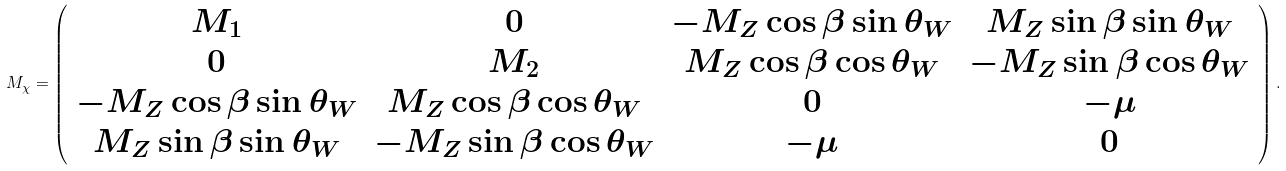Convert formula to latex. <formula><loc_0><loc_0><loc_500><loc_500>M _ { \chi } = \left ( \begin{array} { c c c c } M _ { 1 } & 0 & - M _ { Z } \cos \beta \sin \theta _ { W } & M _ { Z } \sin \beta \sin \theta _ { W } \\ 0 & M _ { 2 } & M _ { Z } \cos \beta \cos \theta _ { W } & - M _ { Z } \sin \beta \cos \theta _ { W } \\ - M _ { Z } \cos \beta \sin \theta _ { W } & M _ { Z } \cos \beta \cos \theta _ { W } & 0 & - \mu \\ M _ { Z } \sin \beta \sin \theta _ { W } & - M _ { Z } \sin \beta \cos \theta _ { W } & - \mu & 0 \end{array} \right ) .</formula> 